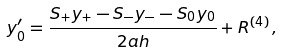<formula> <loc_0><loc_0><loc_500><loc_500>y ^ { \prime } _ { 0 } = \frac { S _ { + } y _ { + } - S _ { - } y _ { - } - S _ { 0 } y _ { 0 } } { 2 a h } + R ^ { ( 4 ) } \, ,</formula> 